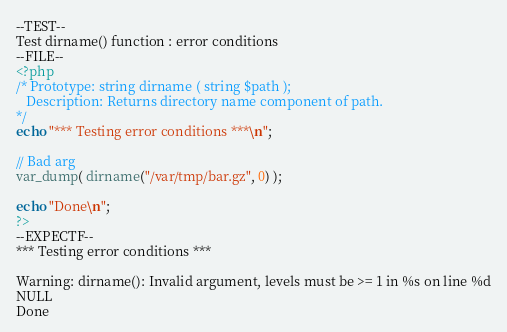Convert code to text. <code><loc_0><loc_0><loc_500><loc_500><_PHP_>--TEST--
Test dirname() function : error conditions
--FILE--
<?php
/* Prototype: string dirname ( string $path );
   Description: Returns directory name component of path.
*/
echo "*** Testing error conditions ***\n";

// Bad arg
var_dump( dirname("/var/tmp/bar.gz", 0) );

echo "Done\n";
?>
--EXPECTF--
*** Testing error conditions ***

Warning: dirname(): Invalid argument, levels must be >= 1 in %s on line %d
NULL
Done
</code> 